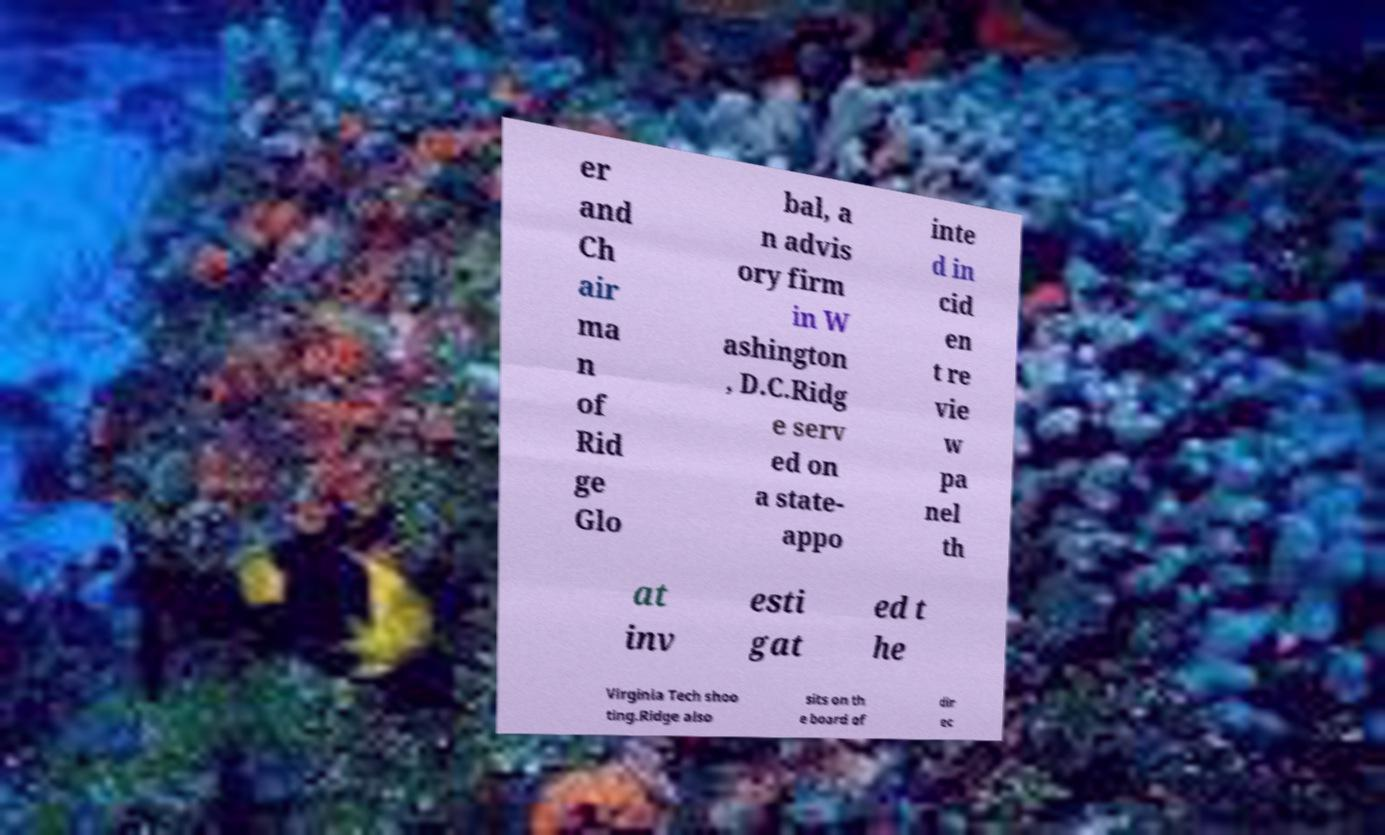For documentation purposes, I need the text within this image transcribed. Could you provide that? er and Ch air ma n of Rid ge Glo bal, a n advis ory firm in W ashington , D.C.Ridg e serv ed on a state- appo inte d in cid en t re vie w pa nel th at inv esti gat ed t he Virginia Tech shoo ting.Ridge also sits on th e board of dir ec 